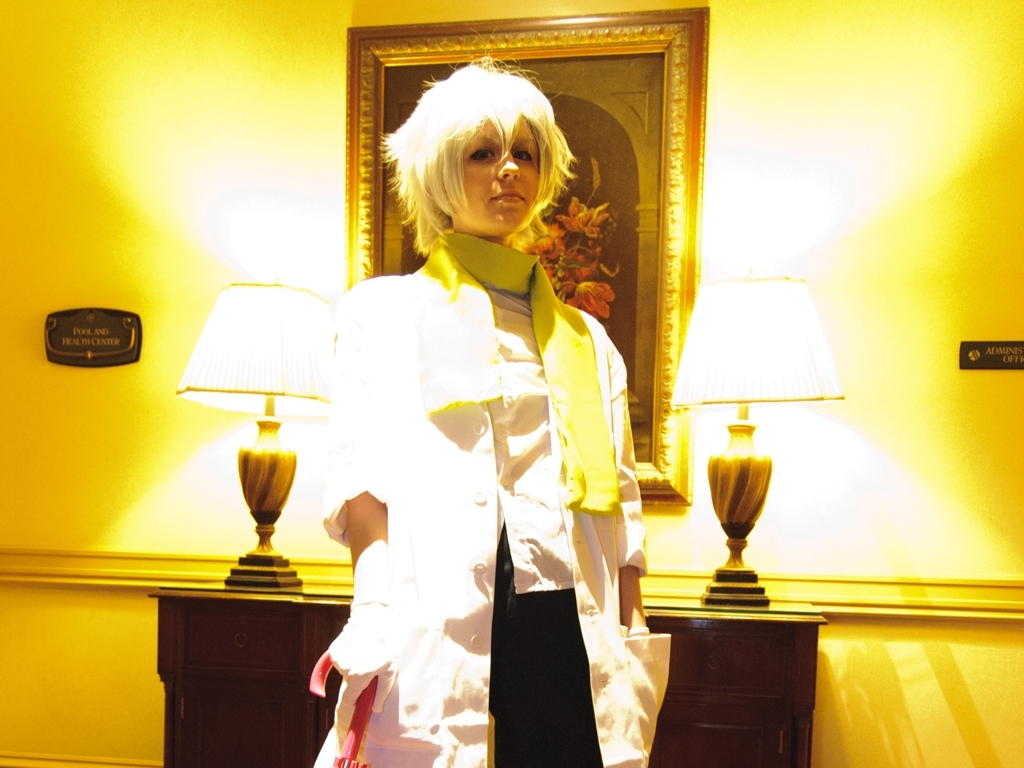What is the atmosphere or mood conveyed by the colors and lighting in this image? The image exudes a warm and somewhat dramatic ambiance, mostly due to the yellow hues dominating the scene. The lighting, although bright and causing some glare, contributes to a sense of intensity and focuses attention on the person in the costume. 